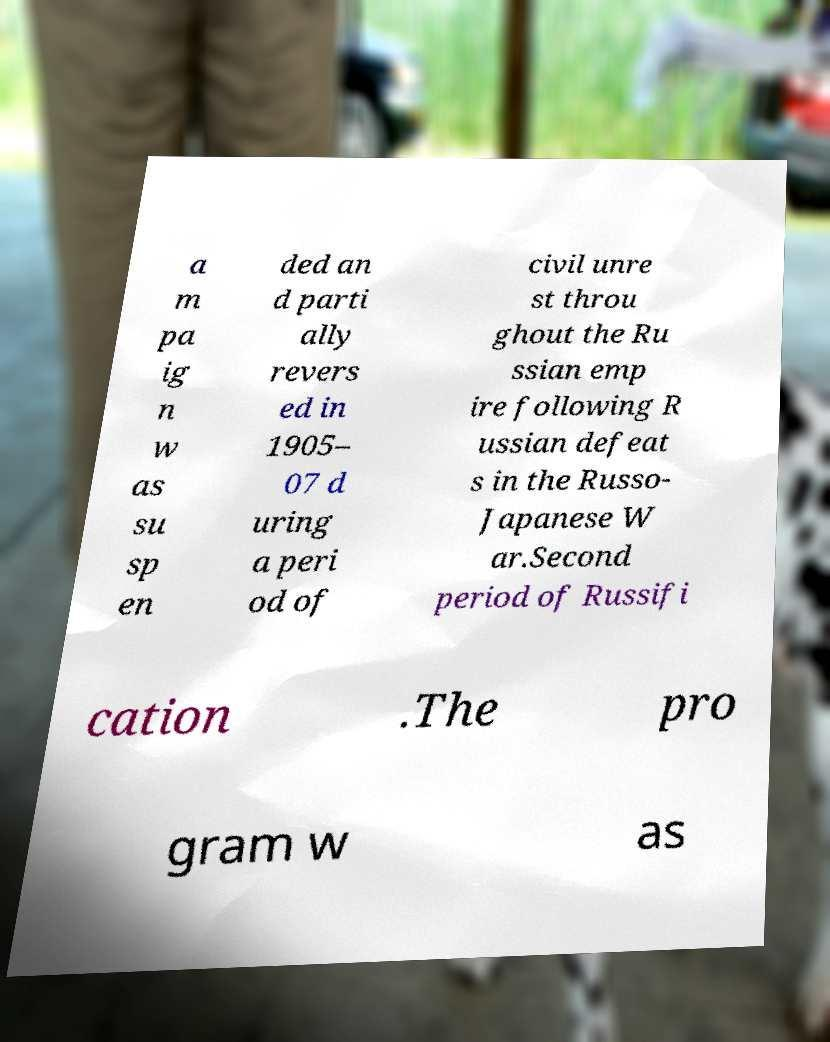There's text embedded in this image that I need extracted. Can you transcribe it verbatim? a m pa ig n w as su sp en ded an d parti ally revers ed in 1905– 07 d uring a peri od of civil unre st throu ghout the Ru ssian emp ire following R ussian defeat s in the Russo- Japanese W ar.Second period of Russifi cation .The pro gram w as 